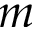<formula> <loc_0><loc_0><loc_500><loc_500>m</formula> 